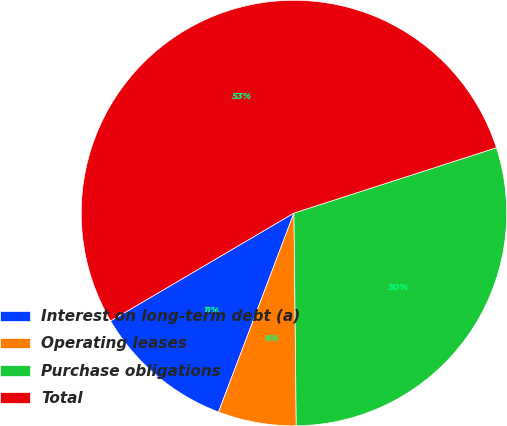Convert chart. <chart><loc_0><loc_0><loc_500><loc_500><pie_chart><fcel>Interest on long-term debt (a)<fcel>Operating leases<fcel>Purchase obligations<fcel>Total<nl><fcel>10.77%<fcel>5.94%<fcel>29.8%<fcel>53.5%<nl></chart> 